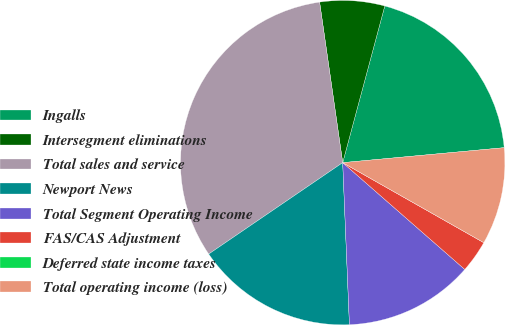<chart> <loc_0><loc_0><loc_500><loc_500><pie_chart><fcel>Ingalls<fcel>Intersegment eliminations<fcel>Total sales and service<fcel>Newport News<fcel>Total Segment Operating Income<fcel>FAS/CAS Adjustment<fcel>Deferred state income taxes<fcel>Total operating income (loss)<nl><fcel>19.35%<fcel>6.45%<fcel>32.25%<fcel>16.13%<fcel>12.9%<fcel>3.23%<fcel>0.0%<fcel>9.68%<nl></chart> 